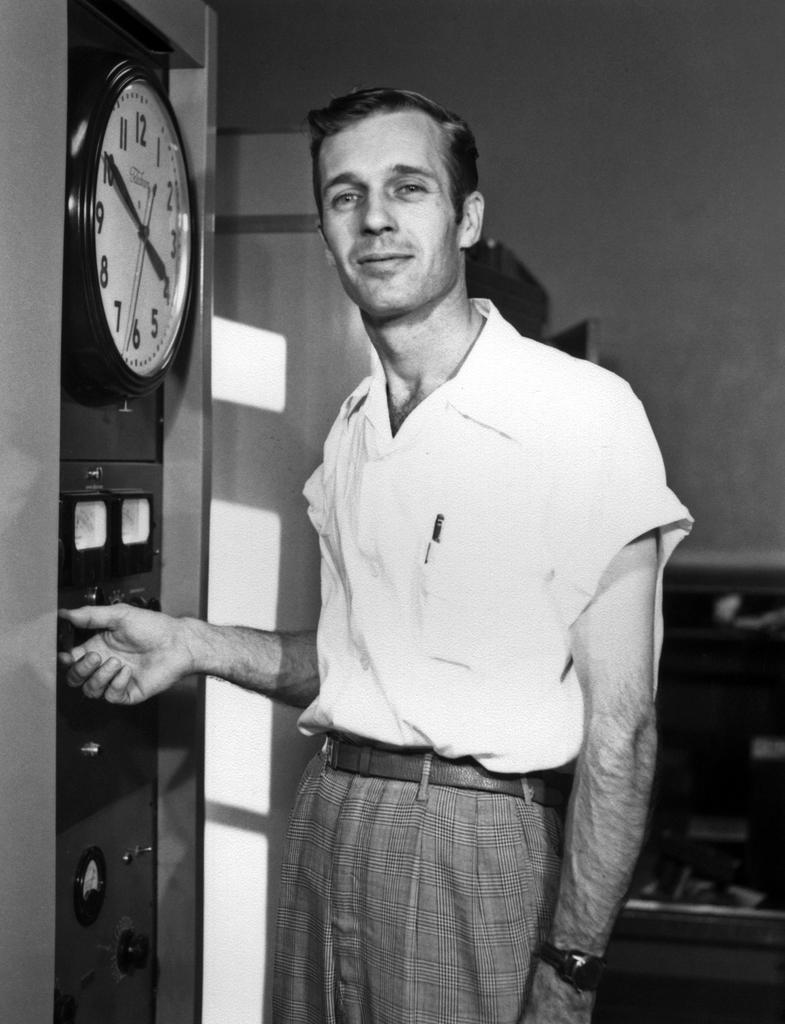Who is the main subject in the image? There is a man standing in the image. Where is the man positioned in the image? The man is in the front of the image. What object can be seen on the left side of the image? There is a clock on the left side of the image. What color scheme is used in the image? The image is black and white in color. What type of net is being used to play chess in the image? There is no net or chess game present in the image; it features a man standing in front of a clock. Can you see the man's hand in the image? The image is black and white, and it does not provide enough detail to determine if the man's hand is visible. 